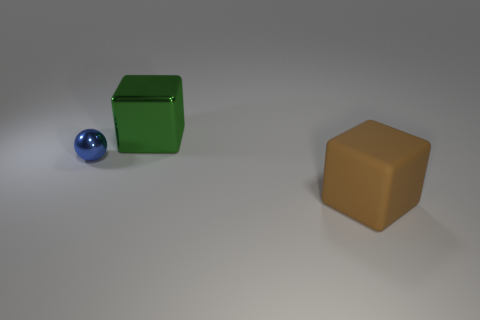Add 1 big green metallic cubes. How many objects exist? 4 Subtract all spheres. How many objects are left? 2 Subtract 0 cyan balls. How many objects are left? 3 Subtract all large brown rubber cylinders. Subtract all big green objects. How many objects are left? 2 Add 1 big matte things. How many big matte things are left? 2 Add 3 large metallic things. How many large metallic things exist? 4 